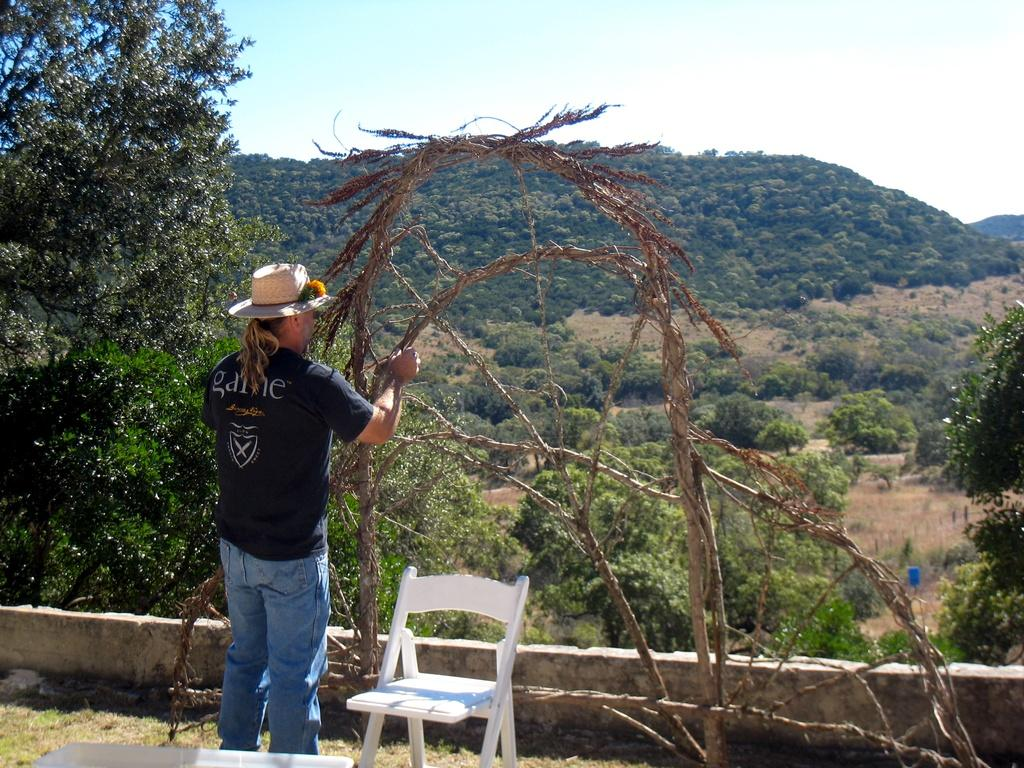What is the main subject of the image? There is a person standing in the image. What is the person doing in the image? The person is doing something, but it is not specified in the facts. What type of natural environment is visible in the image? There are trees and mountains in the image. What piece of furniture is near the person? There is a chair near the person. What is the condition of the sky in the image? The sky is clear and visible in the image. What type of loss is the ghost experiencing in the image? There is no ghost present in the image, so it is not possible to determine any loss they might be experiencing. 